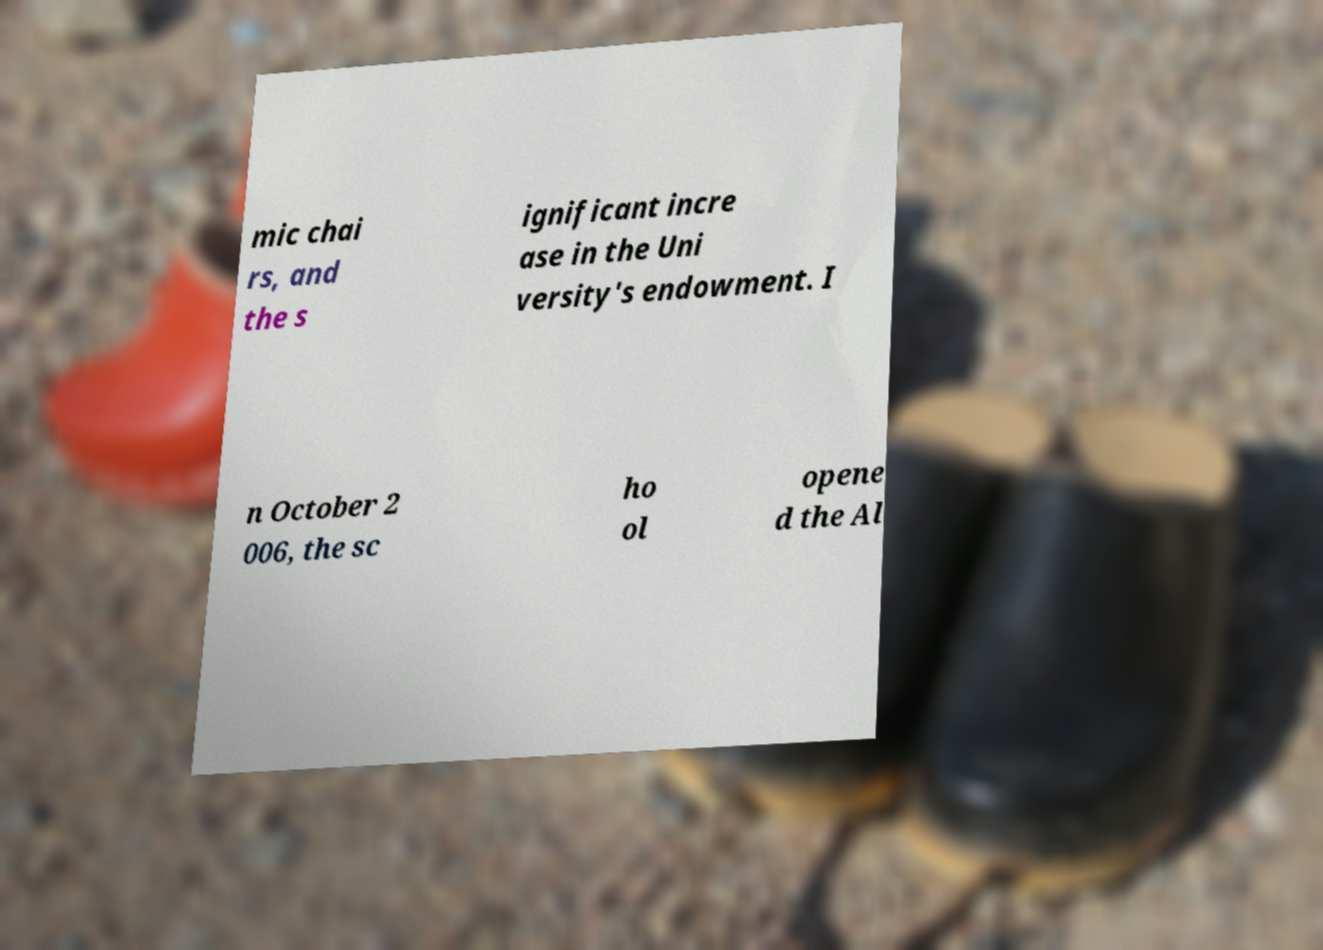I need the written content from this picture converted into text. Can you do that? mic chai rs, and the s ignificant incre ase in the Uni versity's endowment. I n October 2 006, the sc ho ol opene d the Al 